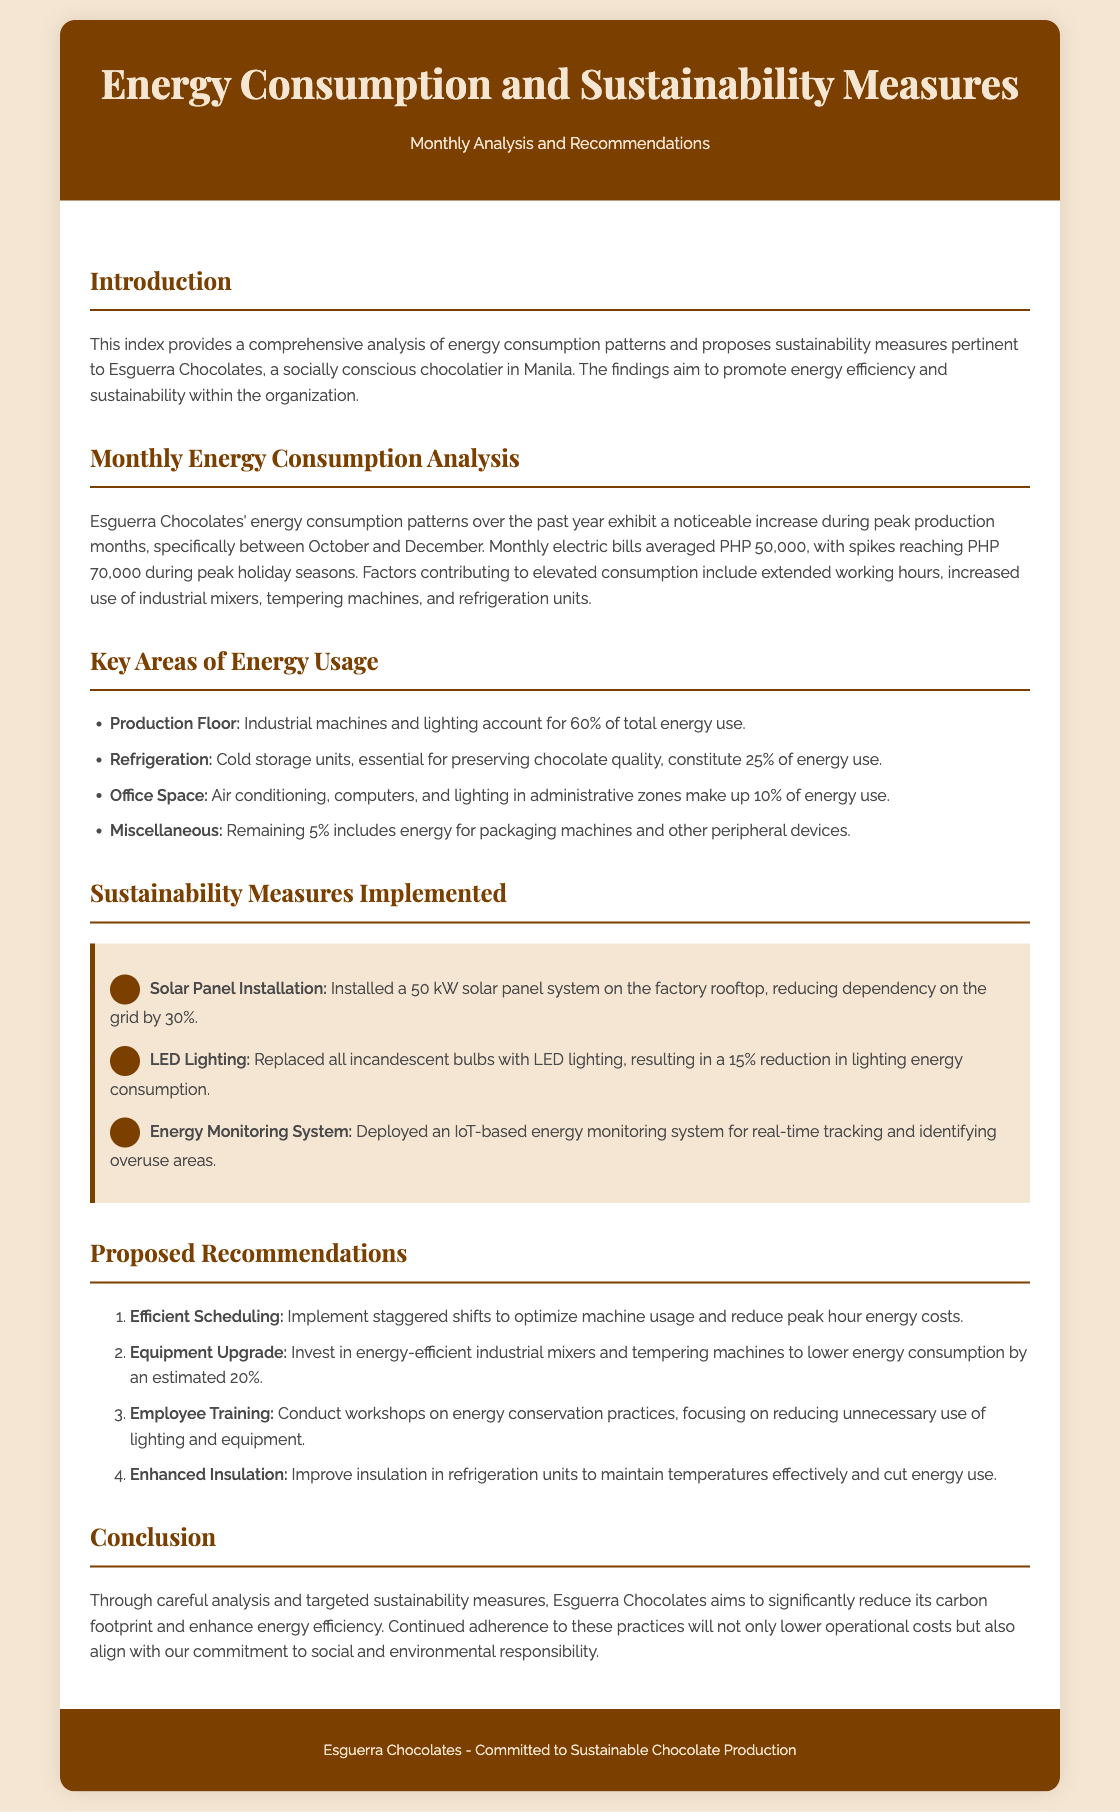What is the average monthly electric bill for Esguerra Chocolates? The average monthly electric bill is noted in the document as PHP 50,000.
Answer: PHP 50,000 What percentage of total energy use does the production floor account for? The document states that the production floor accounts for 60% of total energy use.
Answer: 60% Which sustainability measure reduces grid dependency by 30%? The measure mentioned in the document that reduces grid dependency is the solar panel installation.
Answer: Solar Panel Installation What is the estimated reduction in energy consumption from upgrading equipment? The document estimates a reduction in energy consumption by an estimated 20% from equipment upgrades.
Answer: 20% What environmental responsibility is emphasized in the conclusion? The conclusion highlights the commitment to reducing carbon footprint as a key environmental responsibility.
Answer: Carbon footprint What was the peak electric bill during holiday seasons? The document indicates that spikes reached PHP 70,000 during peak holiday seasons.
Answer: PHP 70,000 What type of energy monitoring system was deployed? The document mentions an IoT-based energy monitoring system as the type deployed.
Answer: IoT-based energy monitoring system What is one proposed recommendation related to employee actions? The document recommends conducting workshops on energy conservation practices as an action related to employees.
Answer: Employee training 